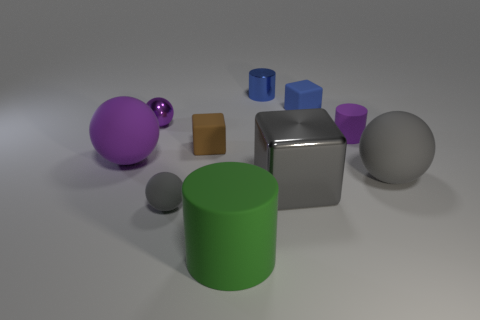Subtract all green balls. Subtract all green blocks. How many balls are left? 4 Subtract all cubes. How many objects are left? 7 Subtract 0 yellow cylinders. How many objects are left? 10 Subtract all big green cylinders. Subtract all shiny cubes. How many objects are left? 8 Add 3 purple metallic things. How many purple metallic things are left? 4 Add 8 large gray metal cubes. How many large gray metal cubes exist? 9 